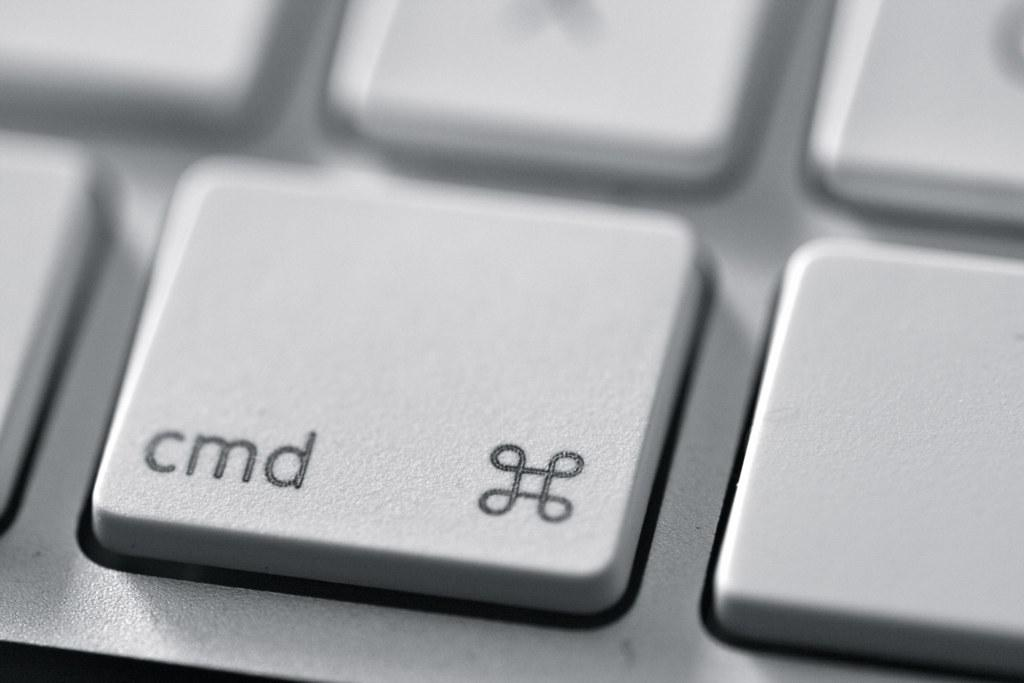Provide a one-sentence caption for the provided image. a mac keyboard with the cmd key in focus. 